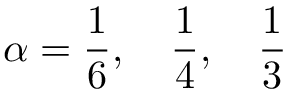<formula> <loc_0><loc_0><loc_500><loc_500>\alpha = \frac { 1 } { 6 } , \quad \frac { 1 } { 4 } , \quad \frac { 1 } { 3 }</formula> 